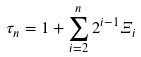Convert formula to latex. <formula><loc_0><loc_0><loc_500><loc_500>\tau _ { n } = 1 + \sum _ { i = 2 } ^ { n } 2 ^ { i - 1 } \Xi _ { i }</formula> 